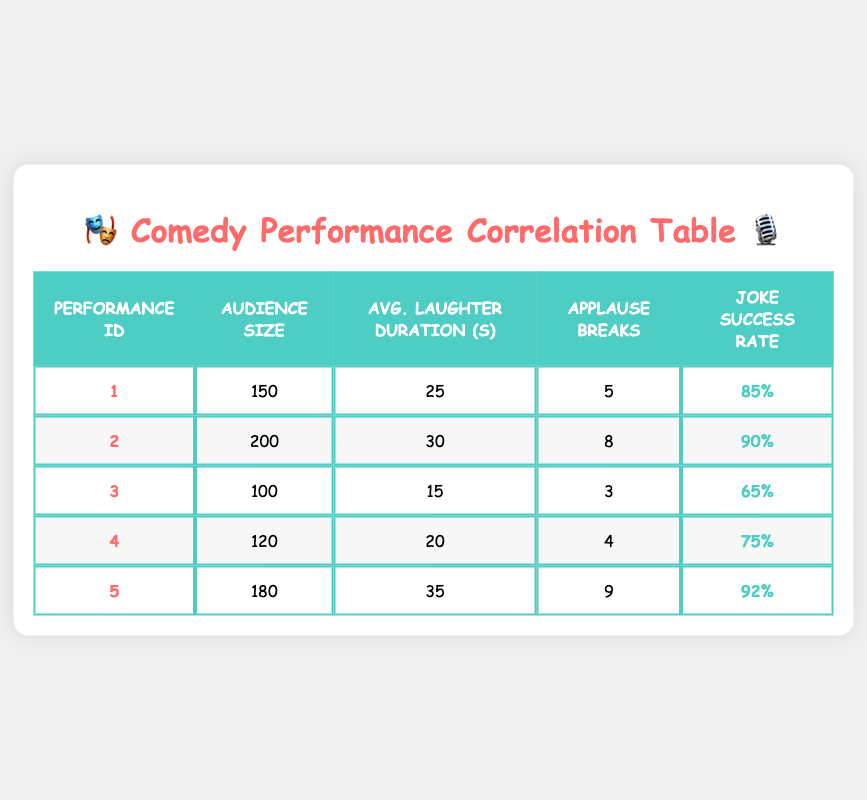What is the joke success rate of performance ID 3? The table shows that the joke success rate for performance ID 3 is listed under the corresponding column, which is 65%.
Answer: 65% What is the average audience size for all performances? To calculate the average audience size, we add the audience sizes: 150 + 200 + 100 + 120 + 180 = 850. There are 5 performances, so we divide by 5: 850/5 = 170.
Answer: 170 Did performance ID 5 have the highest average laughter duration? By reviewing the average laughter duration for each performance, performance ID 5 has a duration of 35 seconds, which is indeed the highest when compared to the others (25, 30, 15, and 20 seconds for IDs 1, 2, 3, and 4 respectively).
Answer: Yes What is the total number of applause breaks across all performances? We sum the applause breaks for all performances: 5 + 8 + 3 + 4 + 9 = 29. Thus, the total number of applause breaks is 29.
Answer: 29 Which performance has the lowest joke success rate? Checking the joke success rates, we find the lowest value is 65% for performance ID 3. This is lower than the other performances which are: 85%, 90%, 75%, and 92%.
Answer: Performance ID 3 What is the average number of applause breaks for performances with a joke success rate above 80%? First, identify performances with a joke success rate above 80%: ID 1 (85%), ID 2 (90%), and ID 5 (92%). Their applause breaks are 5, 8, and 9 respectively. The total is 5 + 8 + 9 = 22. There are 3 performances, so the average is 22/3 = 7.33.
Answer: 7.33 Is there a performance with an audience size of 100? Yes, performance ID 3 has an audience size of 100 people. This can be confirmed by looking at the audience size column for all performances.
Answer: Yes What is the relationship between applause breaks and joke success rate for performance ID 4? Performance ID 4 has 4 applause breaks and a joke success rate of 75%. This shows that a moderate number of applause breaks (4) corresponds to a relatively successful joke rate of 75%, indicating they are linked positively.
Answer: 4 applause breaks, 75% success rate How many performances had an average laughter duration of more than 20 seconds? The performances with average laughter duration over 20 seconds are IDs 2 (30 seconds), 5 (35 seconds), and 1 (25 seconds). This gives us a total of 3 performances.
Answer: 3 performances 